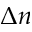<formula> <loc_0><loc_0><loc_500><loc_500>\Delta n</formula> 